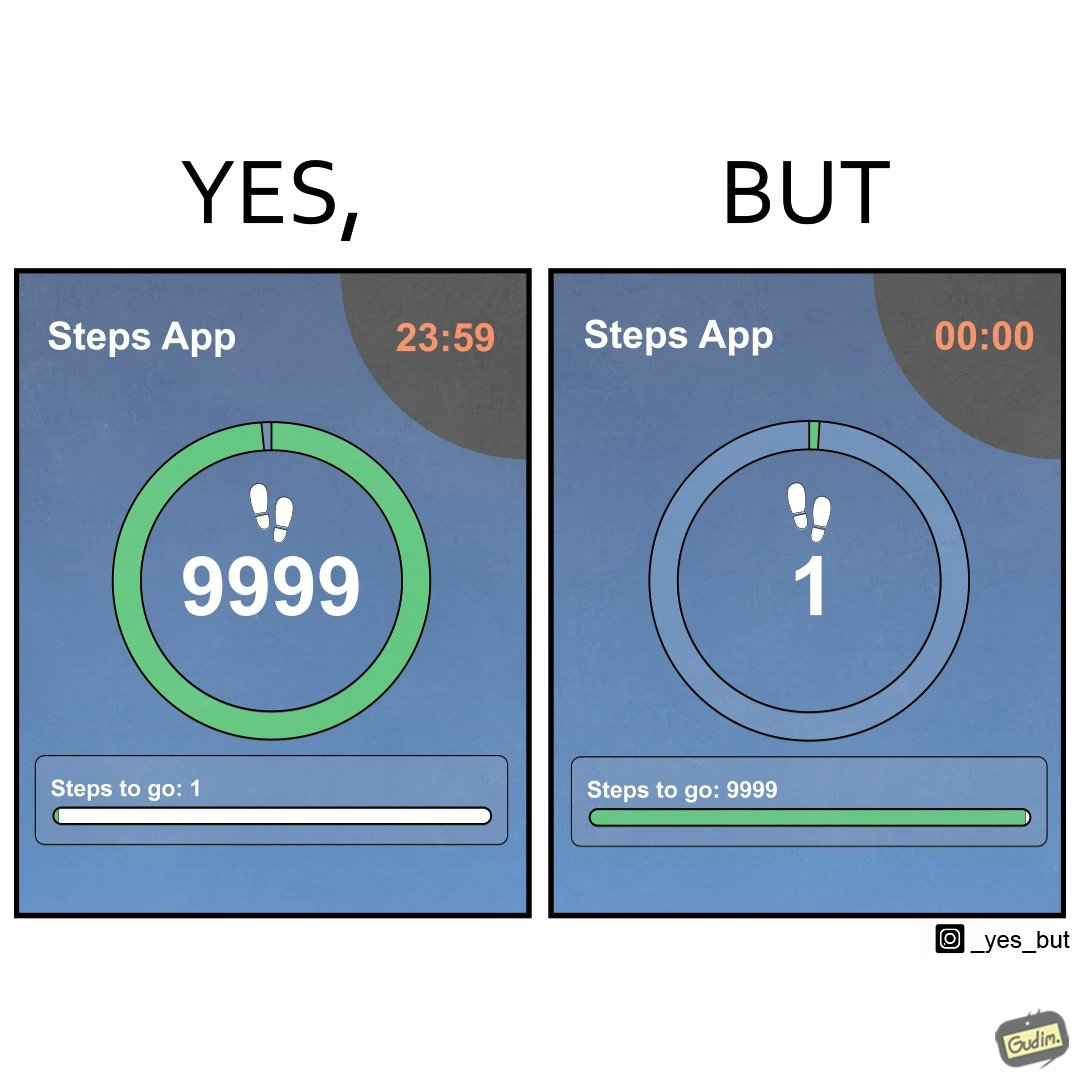Is this a satirical image? Yes, this image is satirical. 